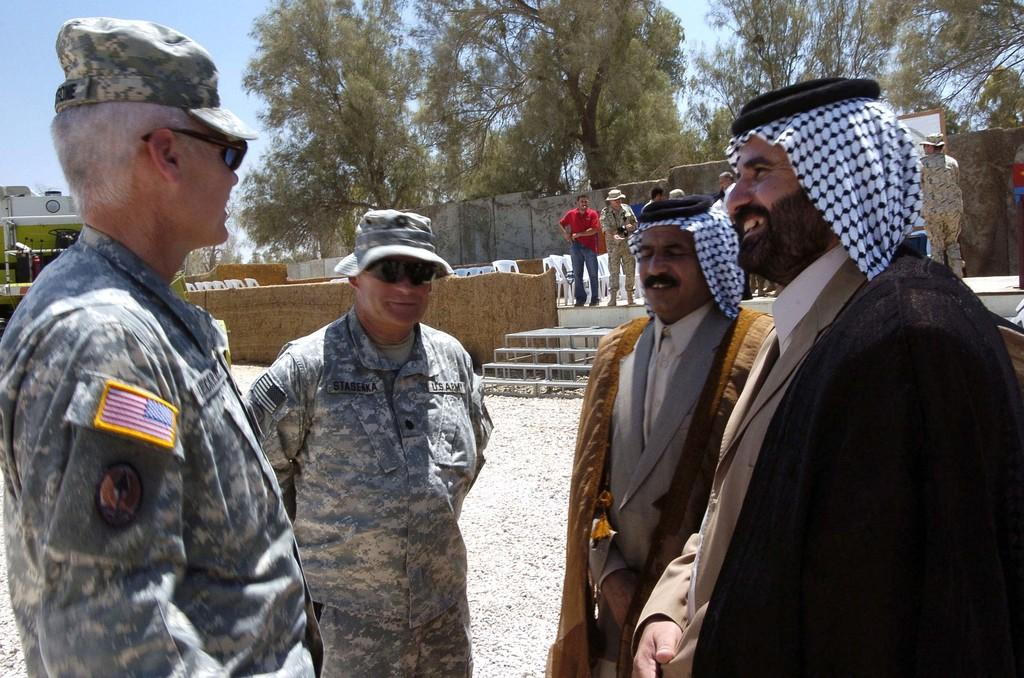How many people are in the image? There are people in the image, but the exact number is not specified. What are some of the people wearing? Some of the people are wearing uniforms. What type of furniture is present in the image? There are chairs in the image. What type of structure is visible in the image? There are walls in the image. What type of natural environment is visible in the image? Trees are visible in the image. What is visible in the background of the image? The sky is visible in the background of the image. What type of bear can be seen interacting with the people in the image? There is no bear present in the image; it only features people, chairs, walls, trees, and the sky. What type of steam is coming out of the pail in the image? There is no pail or steam present in the image. 